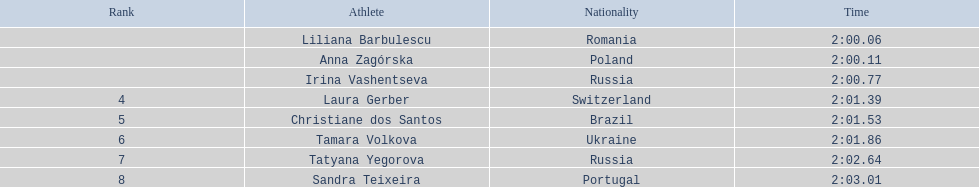What are the appellations of the contenders? Liliana Barbulescu, Anna Zagórska, Irina Vashentseva, Laura Gerber, Christiane dos Santos, Tamara Volkova, Tatyana Yegorova, Sandra Teixeira. Who among the finalists completed the quickest? Liliana Barbulescu. 